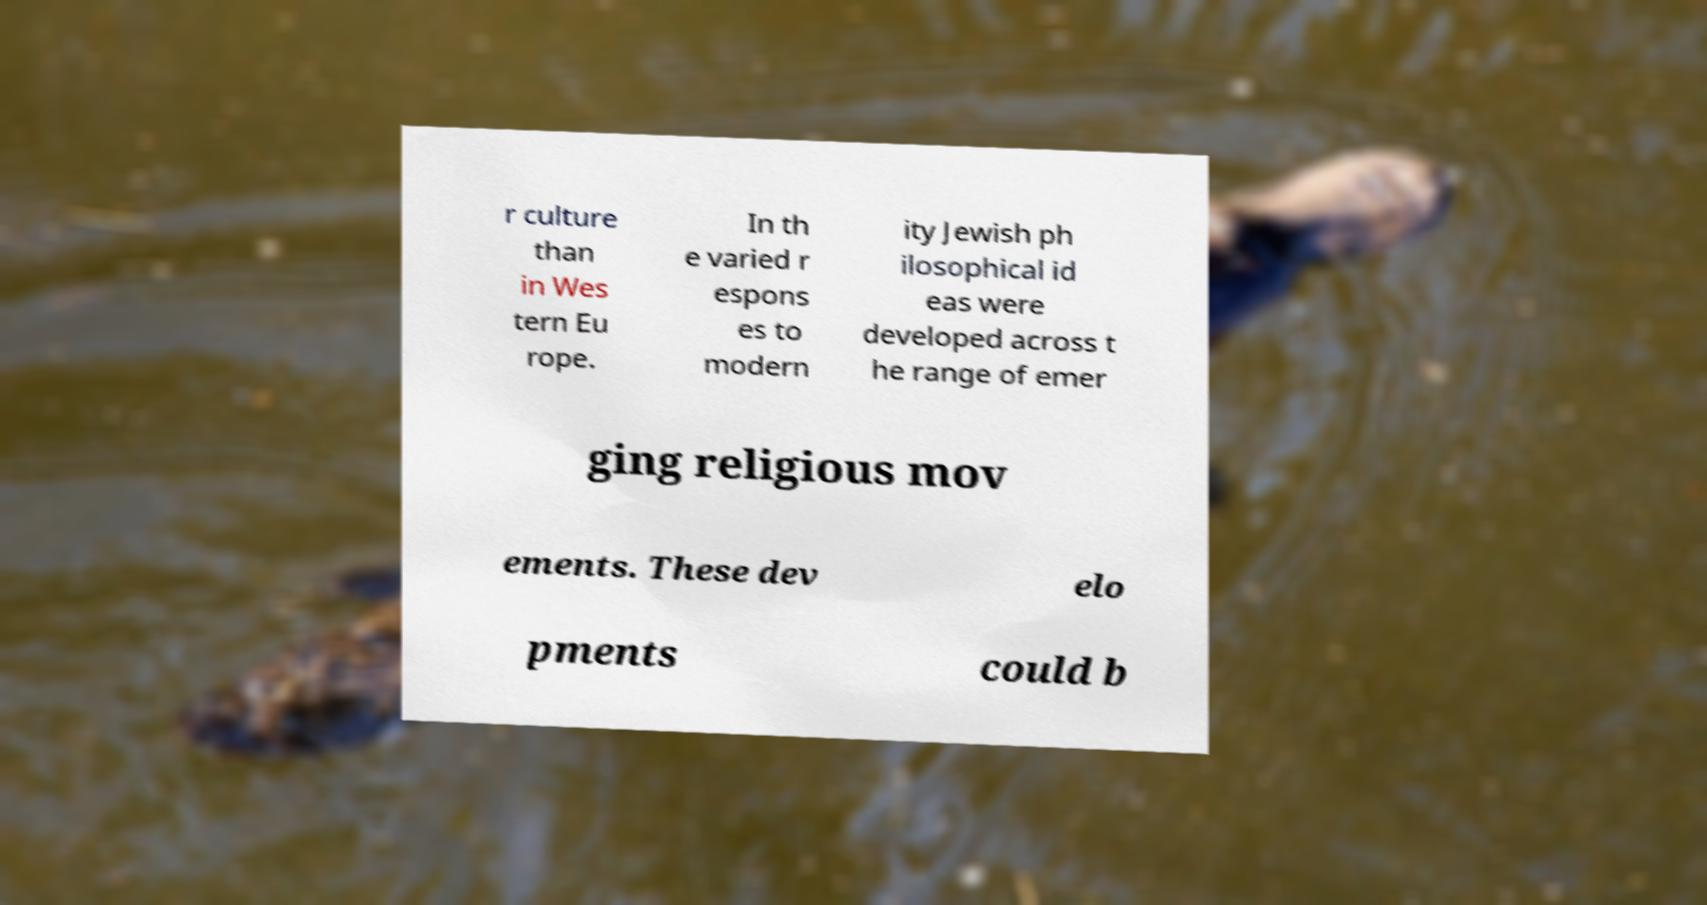What messages or text are displayed in this image? I need them in a readable, typed format. r culture than in Wes tern Eu rope. In th e varied r espons es to modern ity Jewish ph ilosophical id eas were developed across t he range of emer ging religious mov ements. These dev elo pments could b 